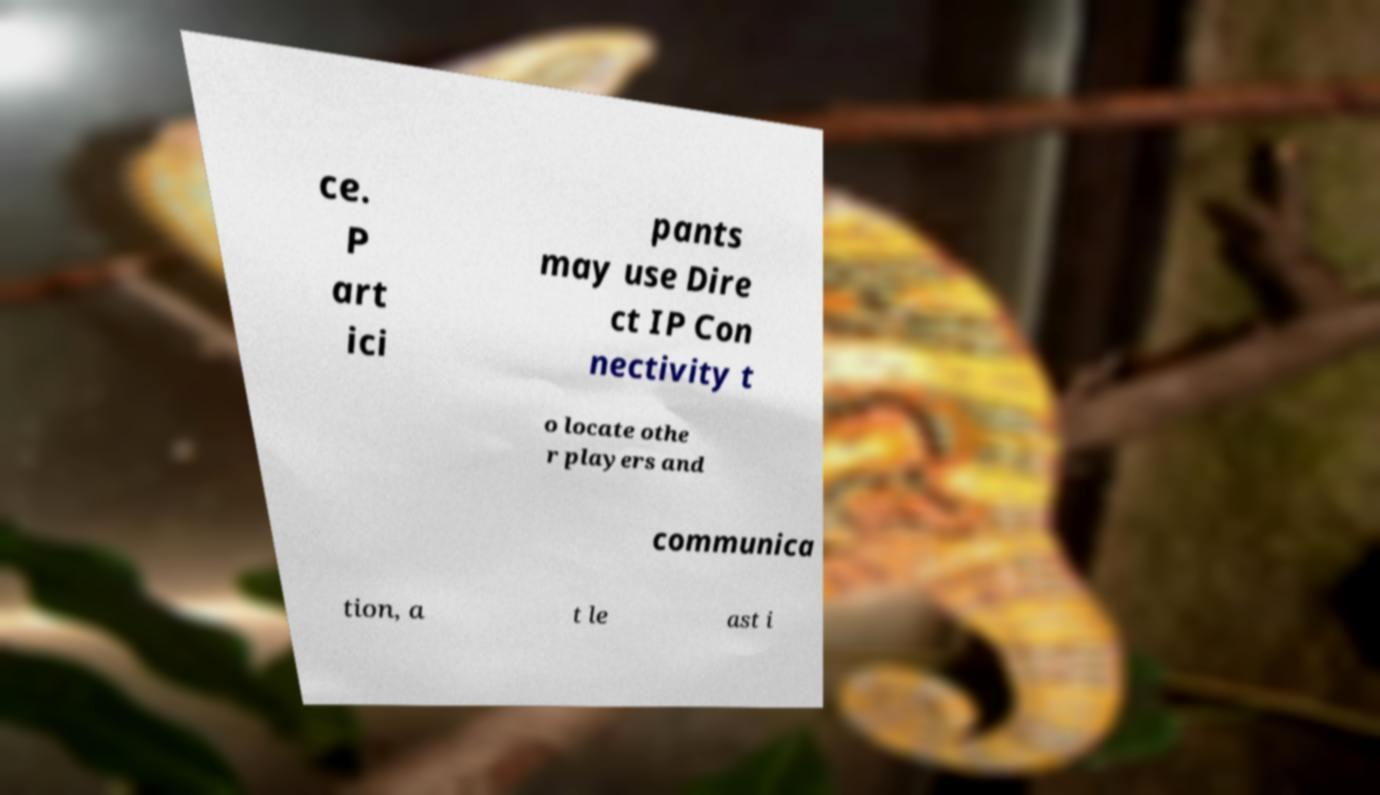Can you accurately transcribe the text from the provided image for me? ce. P art ici pants may use Dire ct IP Con nectivity t o locate othe r players and communica tion, a t le ast i 